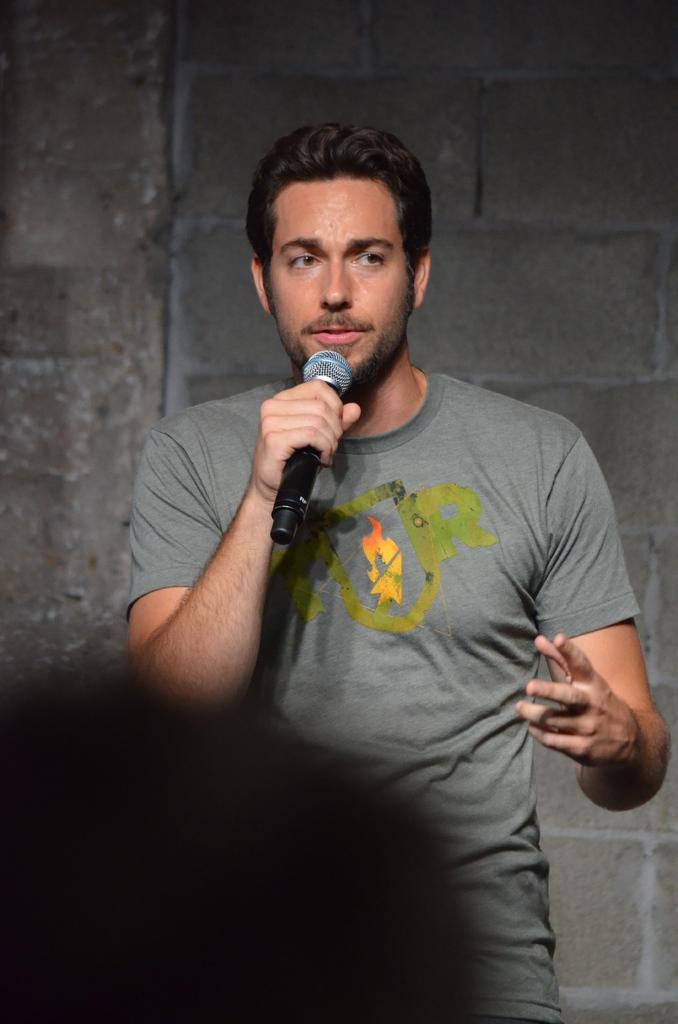What is the person in the image doing? The person is standing and holding a mic. What is the person wearing in the image? The person is wearing a grey t-shirt. What can be seen in the background of the image? There is a grey color wall in the background. Are there any visible effects of lighting in the image? Yes, there are shadows visible in the image. Can you see an airplane drawn with chalk in the image? No, there is no airplane drawn with chalk in the image. Additionally, chalk is not mentioned in the provided facts, so it is not present in the image. 